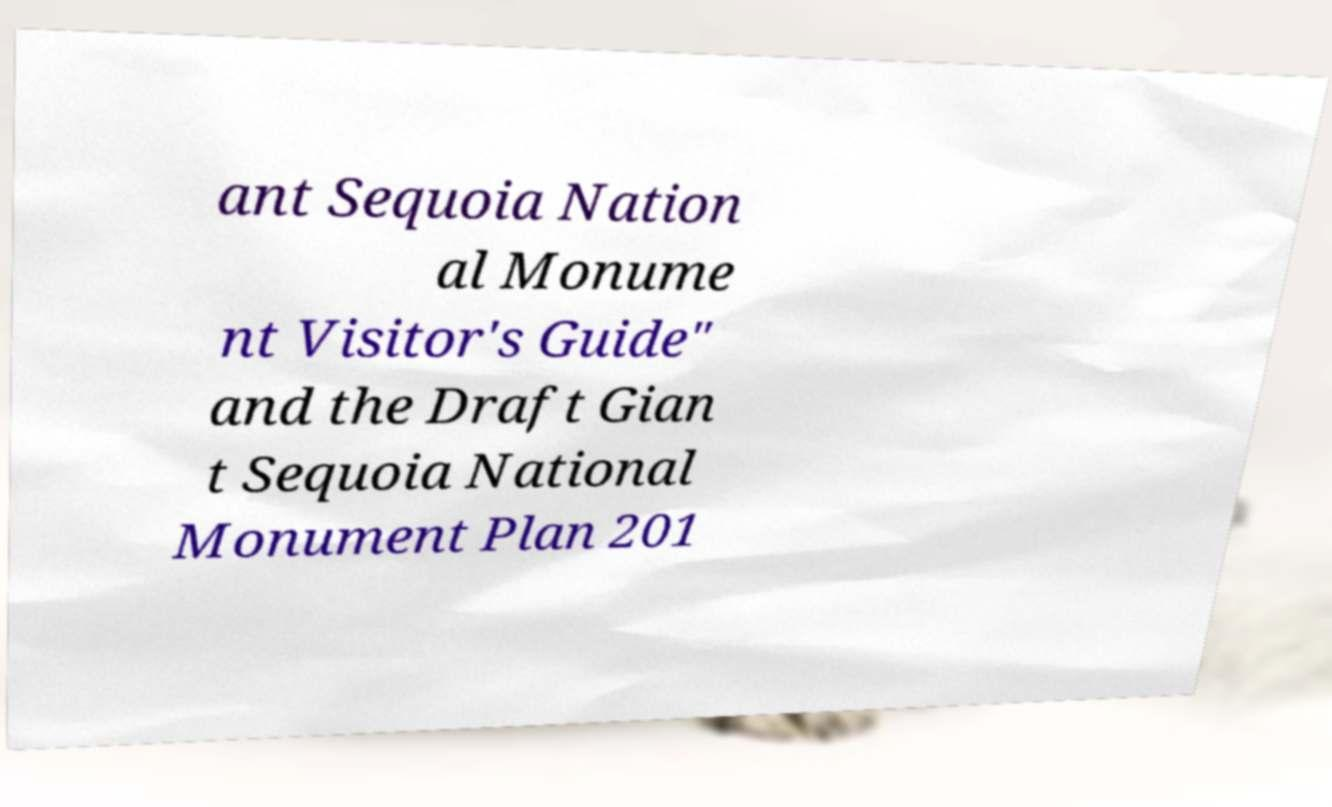For documentation purposes, I need the text within this image transcribed. Could you provide that? ant Sequoia Nation al Monume nt Visitor's Guide" and the Draft Gian t Sequoia National Monument Plan 201 